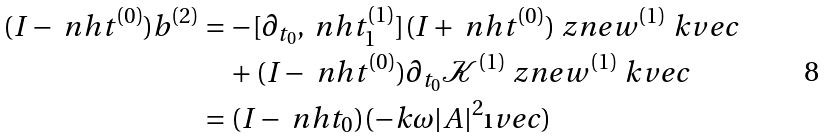<formula> <loc_0><loc_0><loc_500><loc_500>( I - \ n h t ^ { ( 0 ) } ) b ^ { ( 2 ) } & = - [ \partial _ { t _ { 0 } } , \ n h t _ { 1 } ^ { ( 1 ) } ] ( I + \ n h t ^ { ( 0 ) } ) \ z n e w ^ { ( 1 ) } \ k v e c \\ & \quad + ( I - \ n h t ^ { ( 0 ) } ) \partial _ { t _ { 0 } } \mathcal { K } ^ { ( 1 ) } \ z n e w ^ { ( 1 ) } \ k v e c \\ & = ( I - \ n h t _ { 0 } ) ( - k \omega | A | ^ { 2 } \i v e c )</formula> 